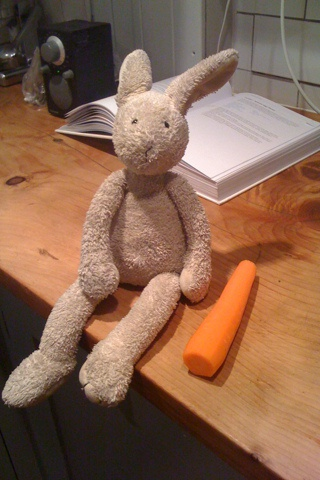Describe the objects in this image and their specific colors. I can see book in black, darkgray, lightgray, and gray tones and carrot in black, red, orange, salmon, and brown tones in this image. 